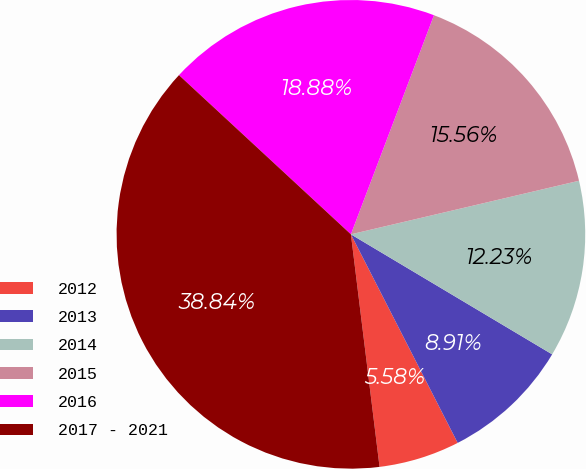Convert chart. <chart><loc_0><loc_0><loc_500><loc_500><pie_chart><fcel>2012<fcel>2013<fcel>2014<fcel>2015<fcel>2016<fcel>2017 - 2021<nl><fcel>5.58%<fcel>8.91%<fcel>12.23%<fcel>15.56%<fcel>18.88%<fcel>38.84%<nl></chart> 